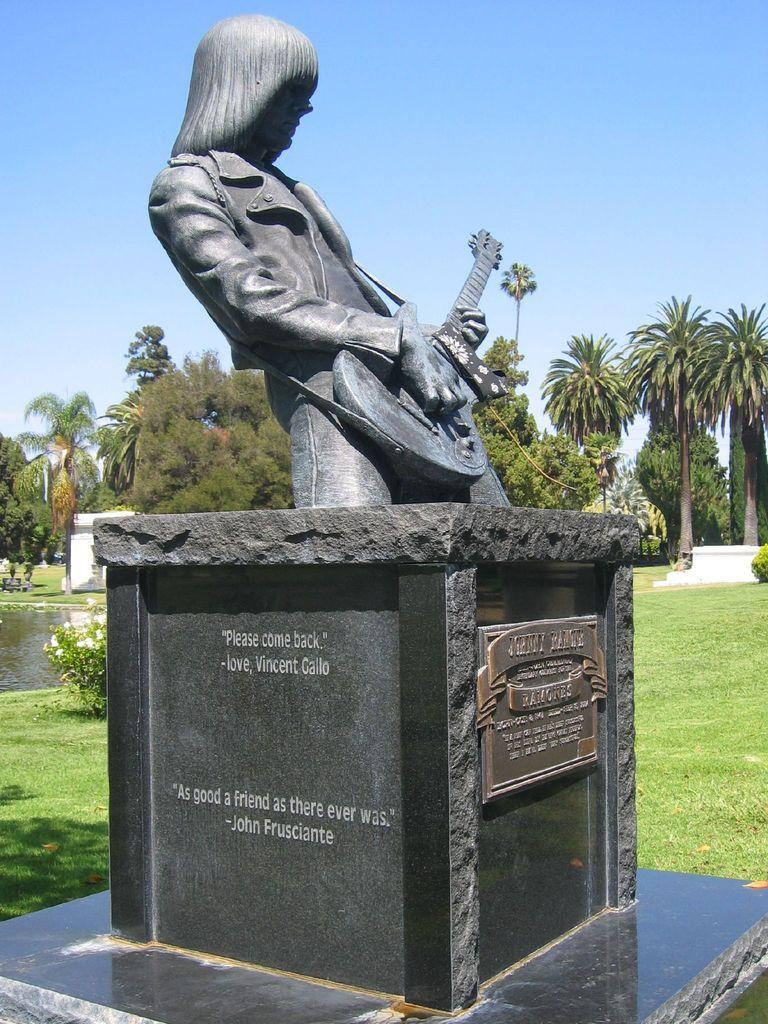What is the main subject in the center of the image? There is a statue in the center of the image. What can be found on the stand of the statue? There is text on the stand of the statue. What type of vegetation is visible in the image? There is a group of trees visible on the backside of the image. What natural element is present in the image? Water is visible in the image. How would you describe the weather condition in the image? The sky appears cloudy in the image. Where can you find the seashore in the image? There is no seashore present in the image. How many apples are hanging from the trees in the image? There are no apples visible in the image; only trees are present. 